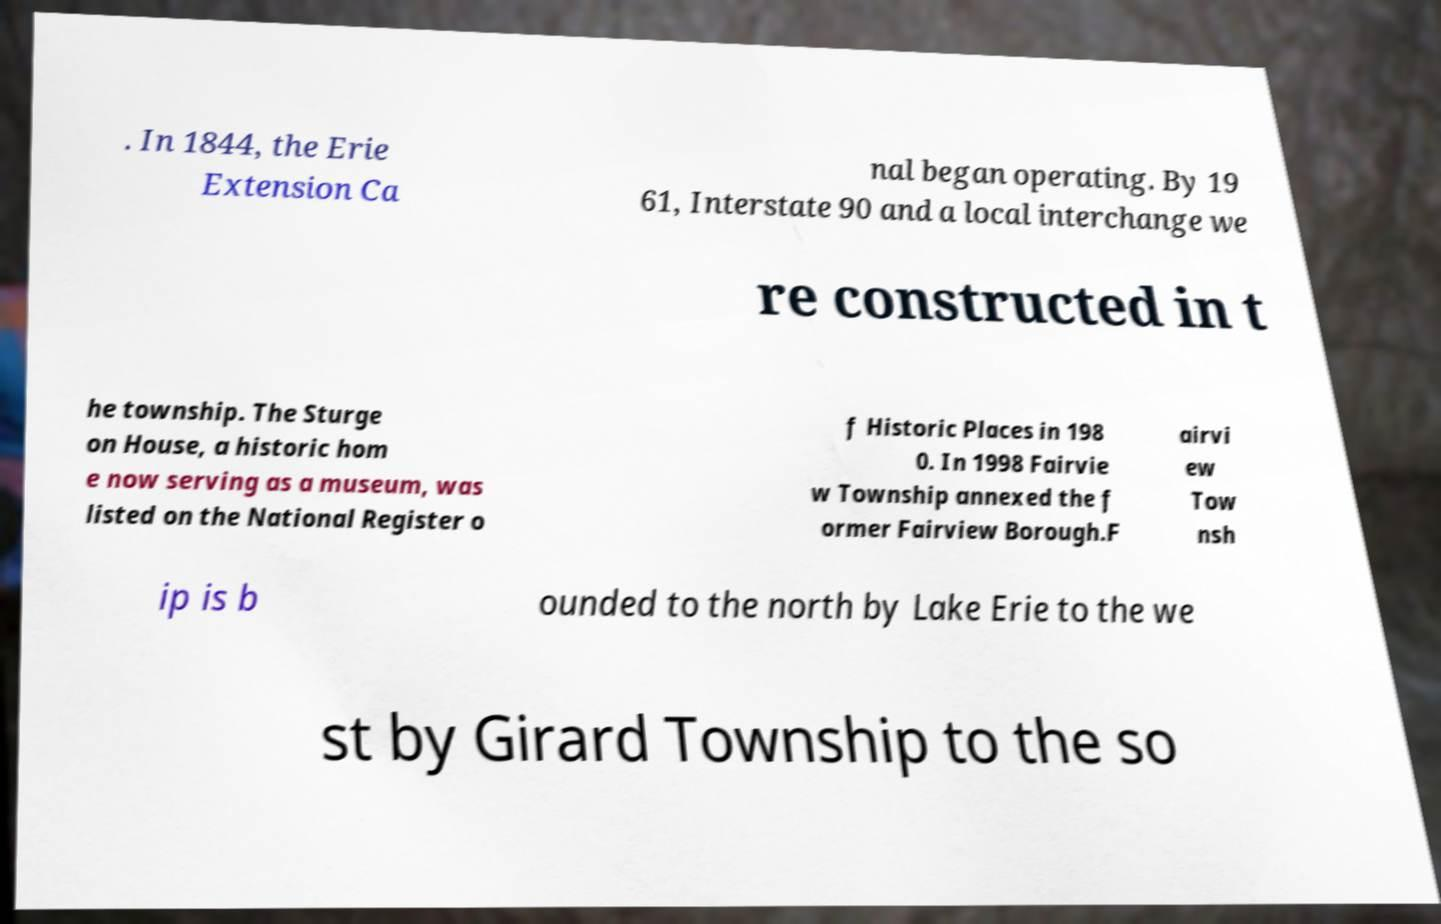There's text embedded in this image that I need extracted. Can you transcribe it verbatim? . In 1844, the Erie Extension Ca nal began operating. By 19 61, Interstate 90 and a local interchange we re constructed in t he township. The Sturge on House, a historic hom e now serving as a museum, was listed on the National Register o f Historic Places in 198 0. In 1998 Fairvie w Township annexed the f ormer Fairview Borough.F airvi ew Tow nsh ip is b ounded to the north by Lake Erie to the we st by Girard Township to the so 